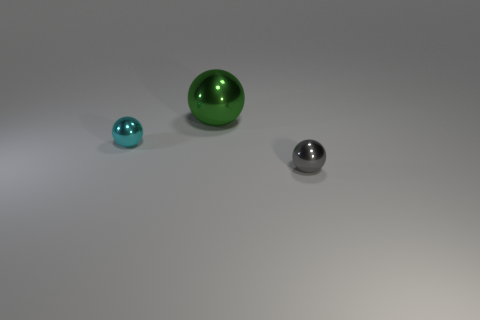What can you infer about the material of these objects based on their appearance? The objects in the image appear to be made of a smooth, reflective material, likely a type of polished metal or glass. The way they reflect light and the clearness of the reflections suggest that the surface is quite smooth and the material has a high gloss finish. Such materials are often used in decorative items or in visual demonstrations of geometry and light. 